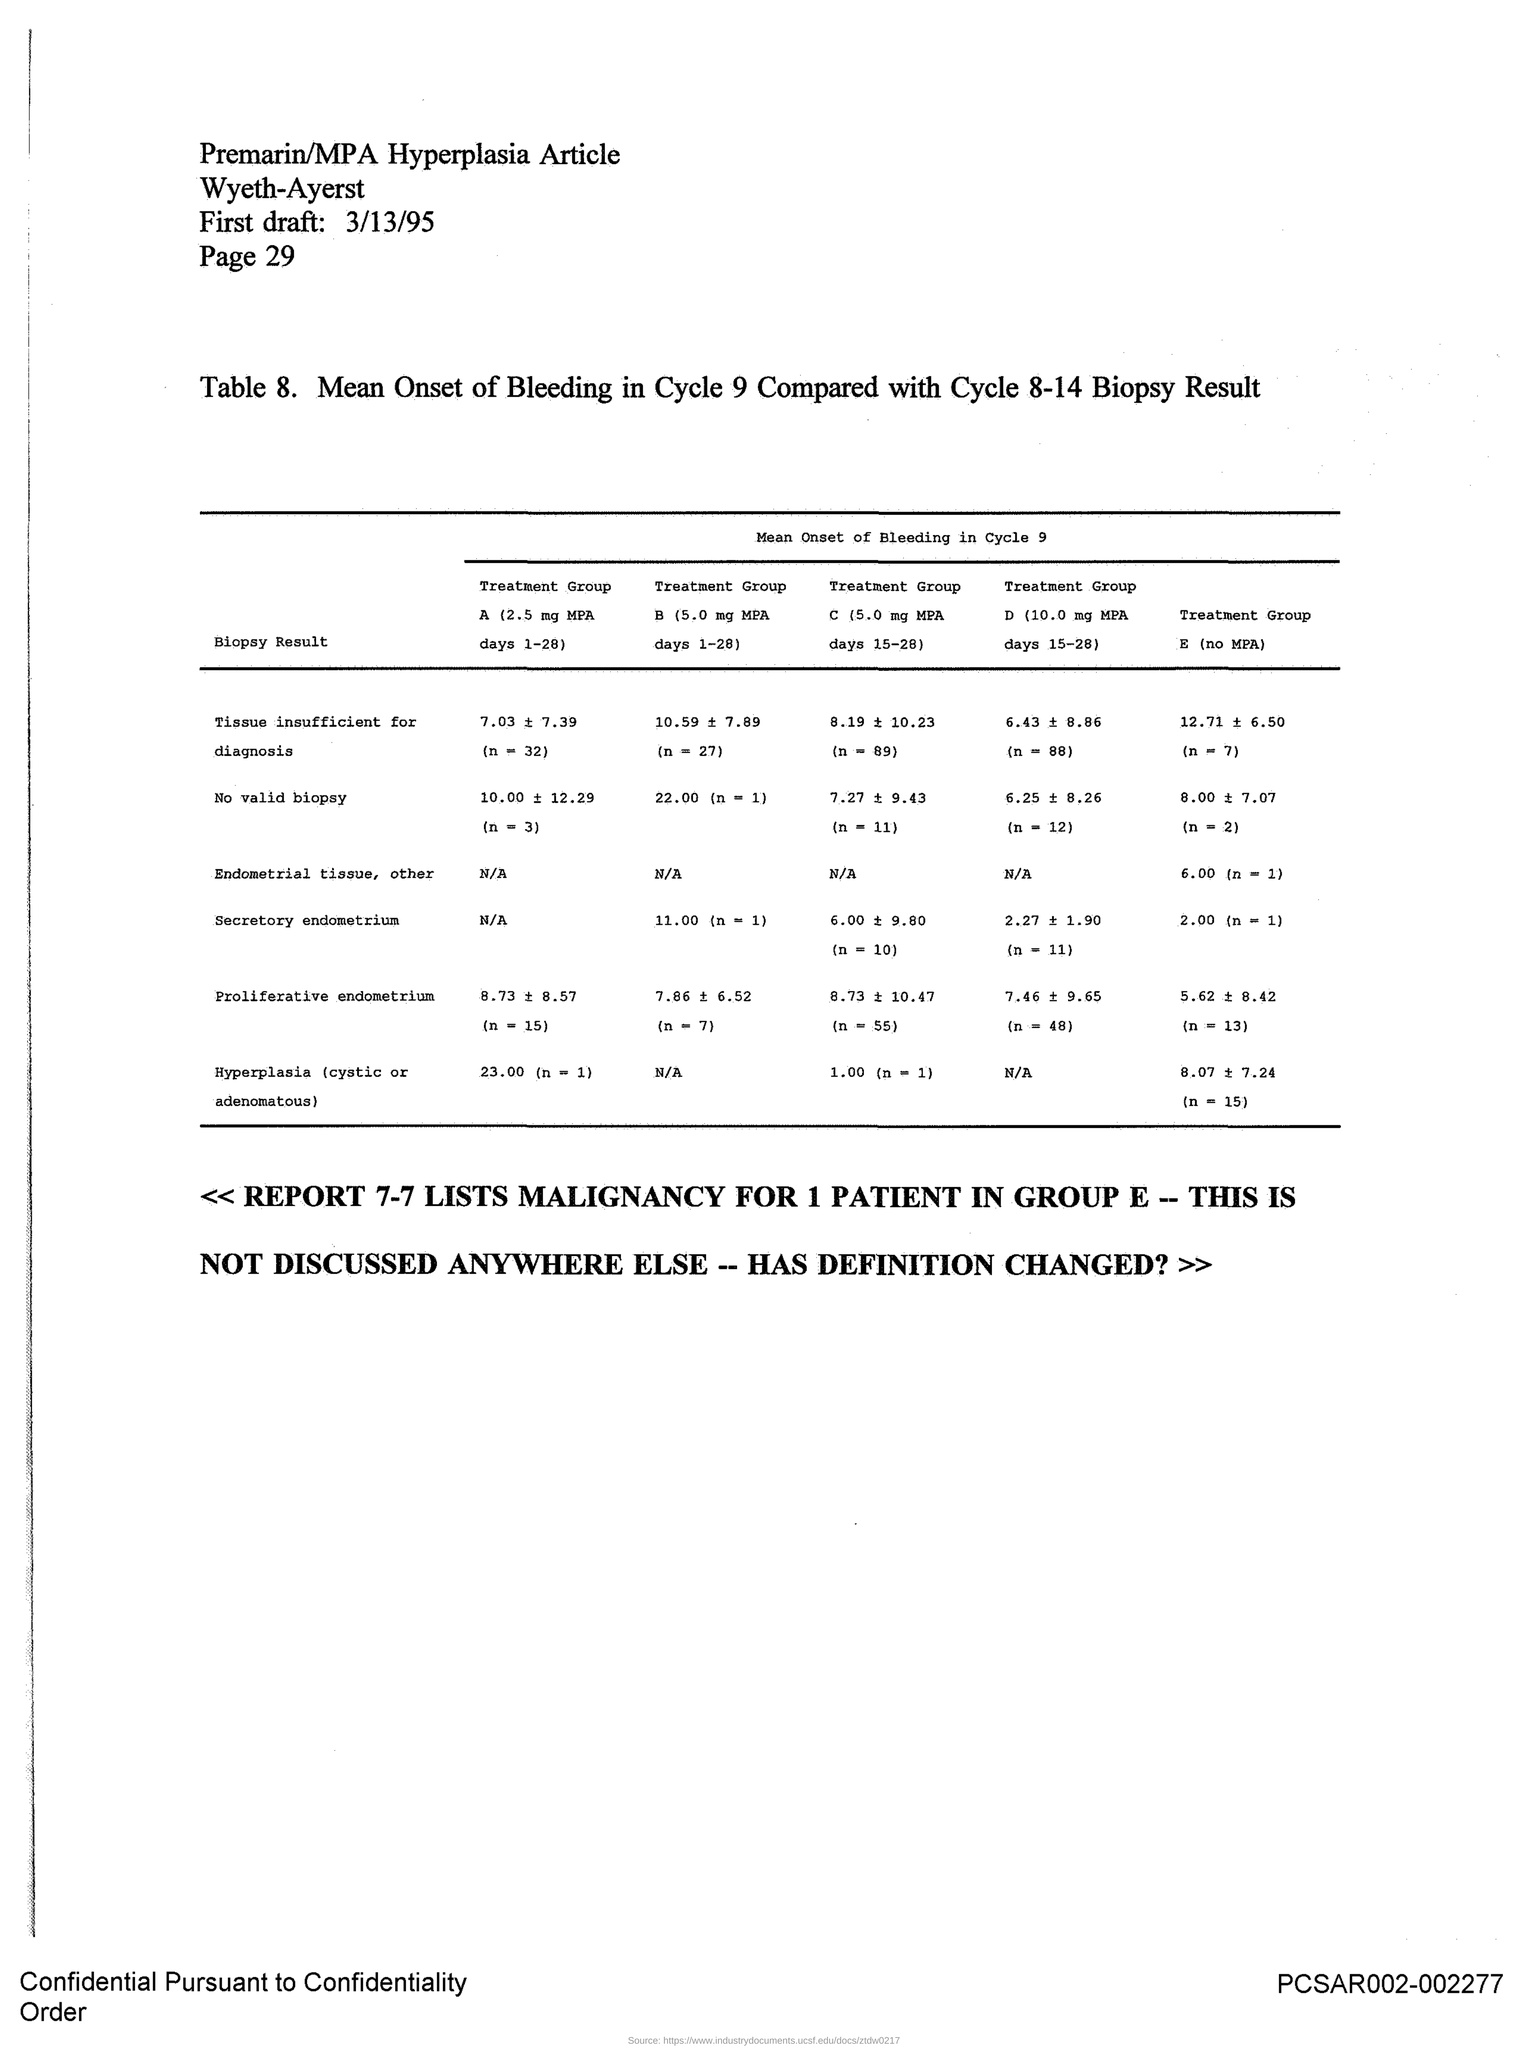Outline some significant characteristics in this image. The first draft date given in the document is March 13, 1995. The article mentioned in the document is "Premarin/MPA Hyperplasia Article. The page number specified in this document is 29. 